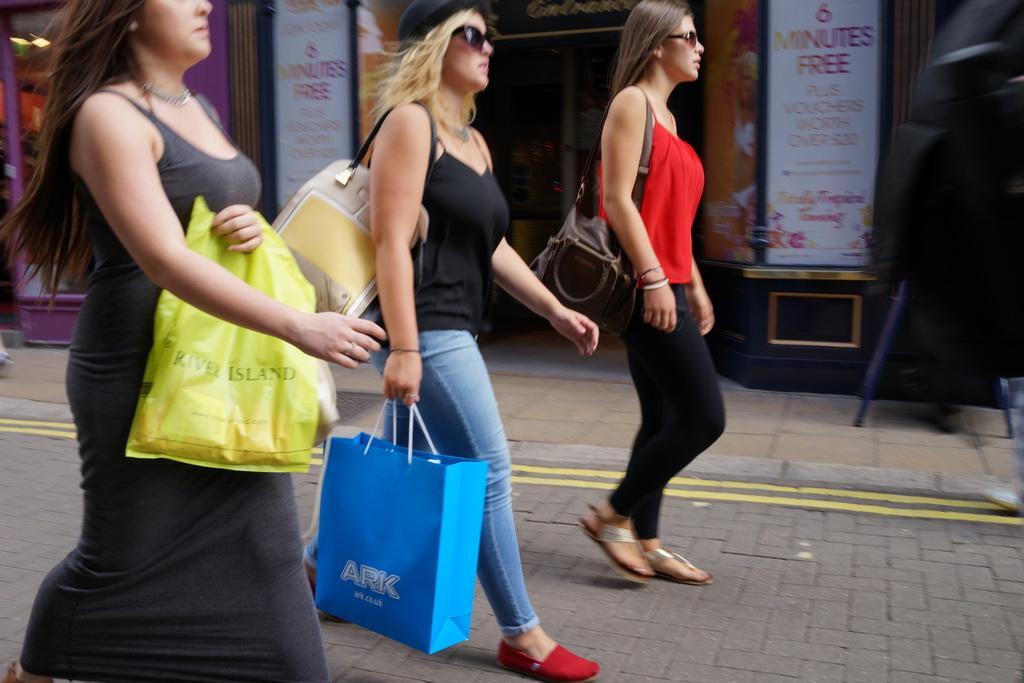In one or two sentences, can you explain what this image depicts? In this picture there are girls in the center of the image and there are posters and stalls in the background area of the image. 